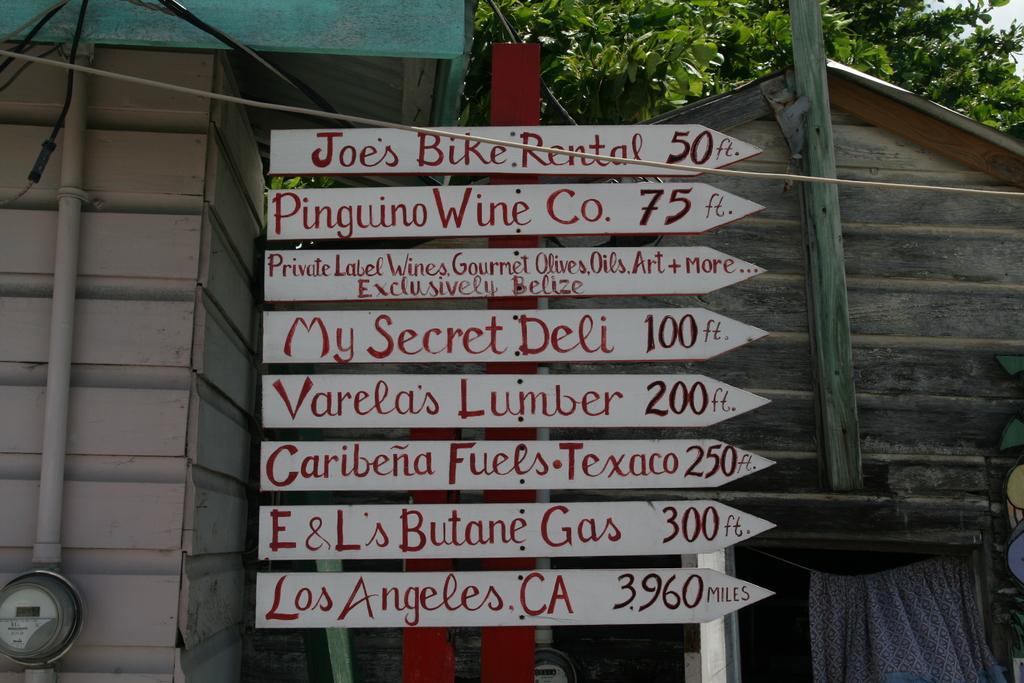How would you summarize this image in a sentence or two? In the center of the image we can see sign boards. In the background we can see houses, tree and sky. 